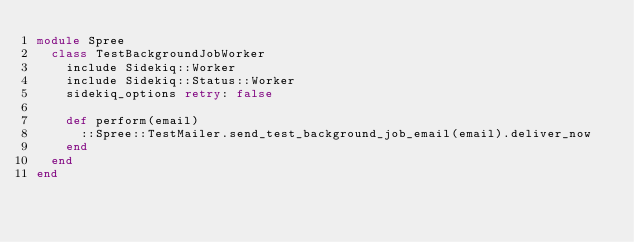<code> <loc_0><loc_0><loc_500><loc_500><_Ruby_>module Spree
  class TestBackgroundJobWorker
    include Sidekiq::Worker
    include Sidekiq::Status::Worker
    sidekiq_options retry: false

    def perform(email)
      ::Spree::TestMailer.send_test_background_job_email(email).deliver_now
    end
  end
end</code> 